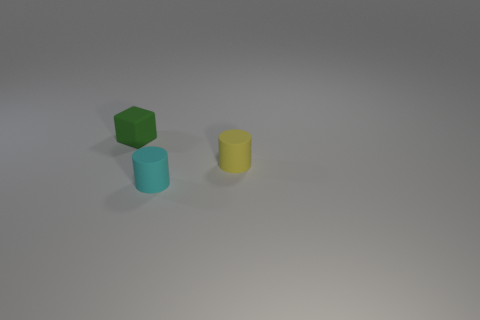Subtract 2 cylinders. How many cylinders are left? 0 Subtract all small cylinders. Subtract all large yellow cylinders. How many objects are left? 1 Add 1 tiny green matte objects. How many tiny green matte objects are left? 2 Add 3 tiny cyan objects. How many tiny cyan objects exist? 4 Add 3 yellow rubber things. How many objects exist? 6 Subtract 0 brown blocks. How many objects are left? 3 Subtract all cubes. How many objects are left? 2 Subtract all blue cylinders. Subtract all blue spheres. How many cylinders are left? 2 Subtract all blue blocks. How many brown cylinders are left? 0 